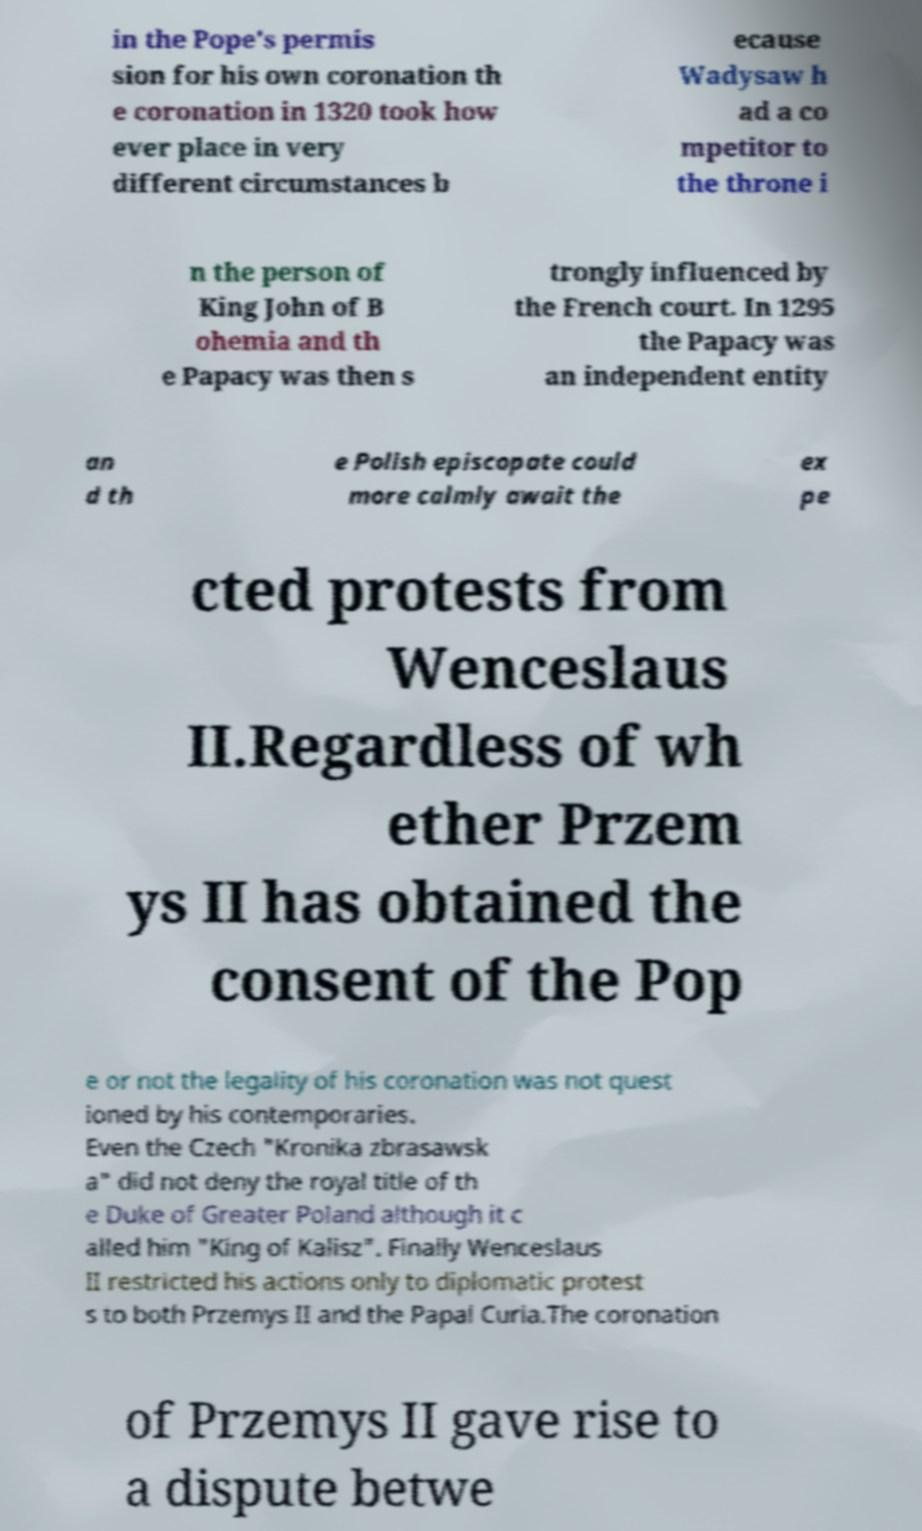For documentation purposes, I need the text within this image transcribed. Could you provide that? in the Pope's permis sion for his own coronation th e coronation in 1320 took how ever place in very different circumstances b ecause Wadysaw h ad a co mpetitor to the throne i n the person of King John of B ohemia and th e Papacy was then s trongly influenced by the French court. In 1295 the Papacy was an independent entity an d th e Polish episcopate could more calmly await the ex pe cted protests from Wenceslaus II.Regardless of wh ether Przem ys II has obtained the consent of the Pop e or not the legality of his coronation was not quest ioned by his contemporaries. Even the Czech "Kronika zbrasawsk a" did not deny the royal title of th e Duke of Greater Poland although it c alled him "King of Kalisz". Finally Wenceslaus II restricted his actions only to diplomatic protest s to both Przemys II and the Papal Curia.The coronation of Przemys II gave rise to a dispute betwe 